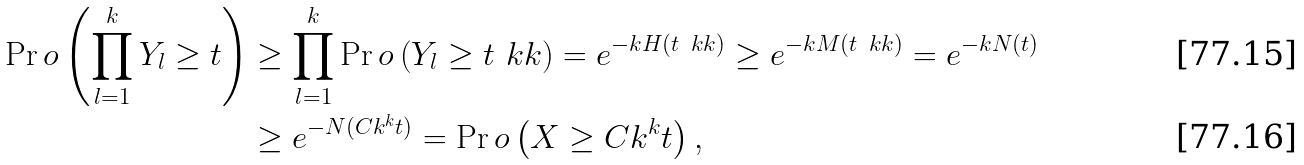Convert formula to latex. <formula><loc_0><loc_0><loc_500><loc_500>\Pr o \left ( \prod _ { l = 1 } ^ { k } Y _ { l } \geq t \right ) & \geq \prod _ { l = 1 } ^ { k } \Pr o \left ( Y _ { l } \geq t ^ { \ } k k \right ) = e ^ { - k H ( t ^ { \ } k k ) } \geq e ^ { - k M ( t ^ { \ } k k ) } = e ^ { - k N ( t ) } \\ & \geq e ^ { - N ( C k ^ { k } t ) } = \Pr o \left ( X \geq C k ^ { k } t \right ) ,</formula> 